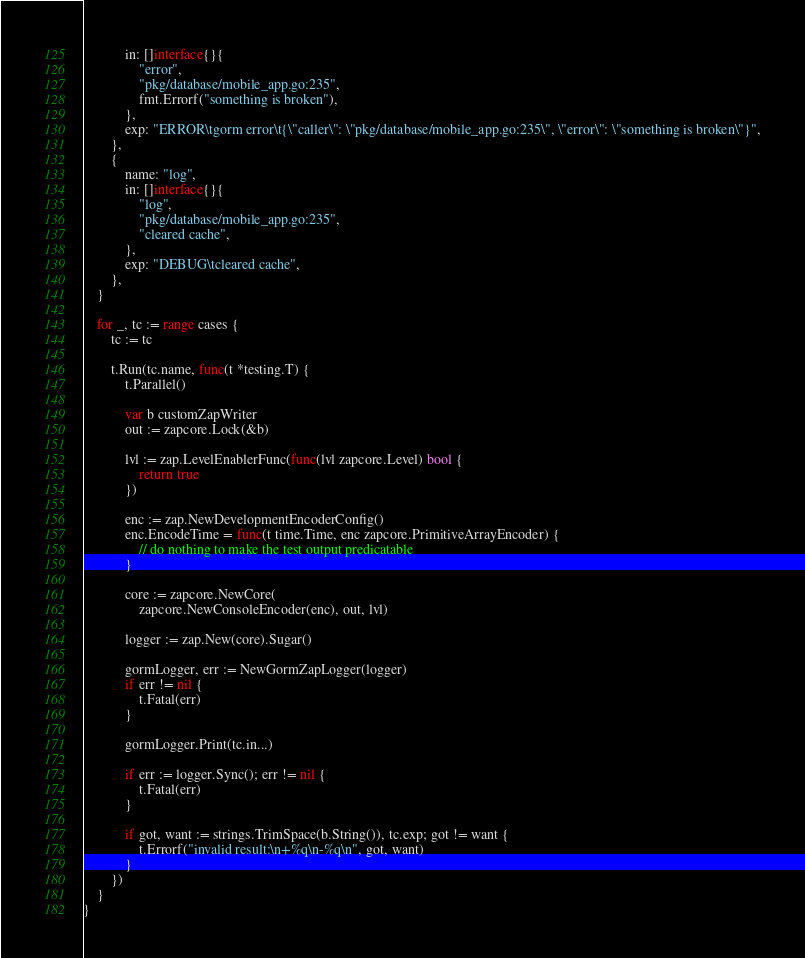<code> <loc_0><loc_0><loc_500><loc_500><_Go_>			in: []interface{}{
				"error",
				"pkg/database/mobile_app.go:235",
				fmt.Errorf("something is broken"),
			},
			exp: "ERROR\tgorm error\t{\"caller\": \"pkg/database/mobile_app.go:235\", \"error\": \"something is broken\"}",
		},
		{
			name: "log",
			in: []interface{}{
				"log",
				"pkg/database/mobile_app.go:235",
				"cleared cache",
			},
			exp: "DEBUG\tcleared cache",
		},
	}

	for _, tc := range cases {
		tc := tc

		t.Run(tc.name, func(t *testing.T) {
			t.Parallel()

			var b customZapWriter
			out := zapcore.Lock(&b)

			lvl := zap.LevelEnablerFunc(func(lvl zapcore.Level) bool {
				return true
			})

			enc := zap.NewDevelopmentEncoderConfig()
			enc.EncodeTime = func(t time.Time, enc zapcore.PrimitiveArrayEncoder) {
				// do nothing to make the test output predicatable
			}

			core := zapcore.NewCore(
				zapcore.NewConsoleEncoder(enc), out, lvl)

			logger := zap.New(core).Sugar()

			gormLogger, err := NewGormZapLogger(logger)
			if err != nil {
				t.Fatal(err)
			}

			gormLogger.Print(tc.in...)

			if err := logger.Sync(); err != nil {
				t.Fatal(err)
			}

			if got, want := strings.TrimSpace(b.String()), tc.exp; got != want {
				t.Errorf("invalid result:\n+%q\n-%q\n", got, want)
			}
		})
	}
}
</code> 